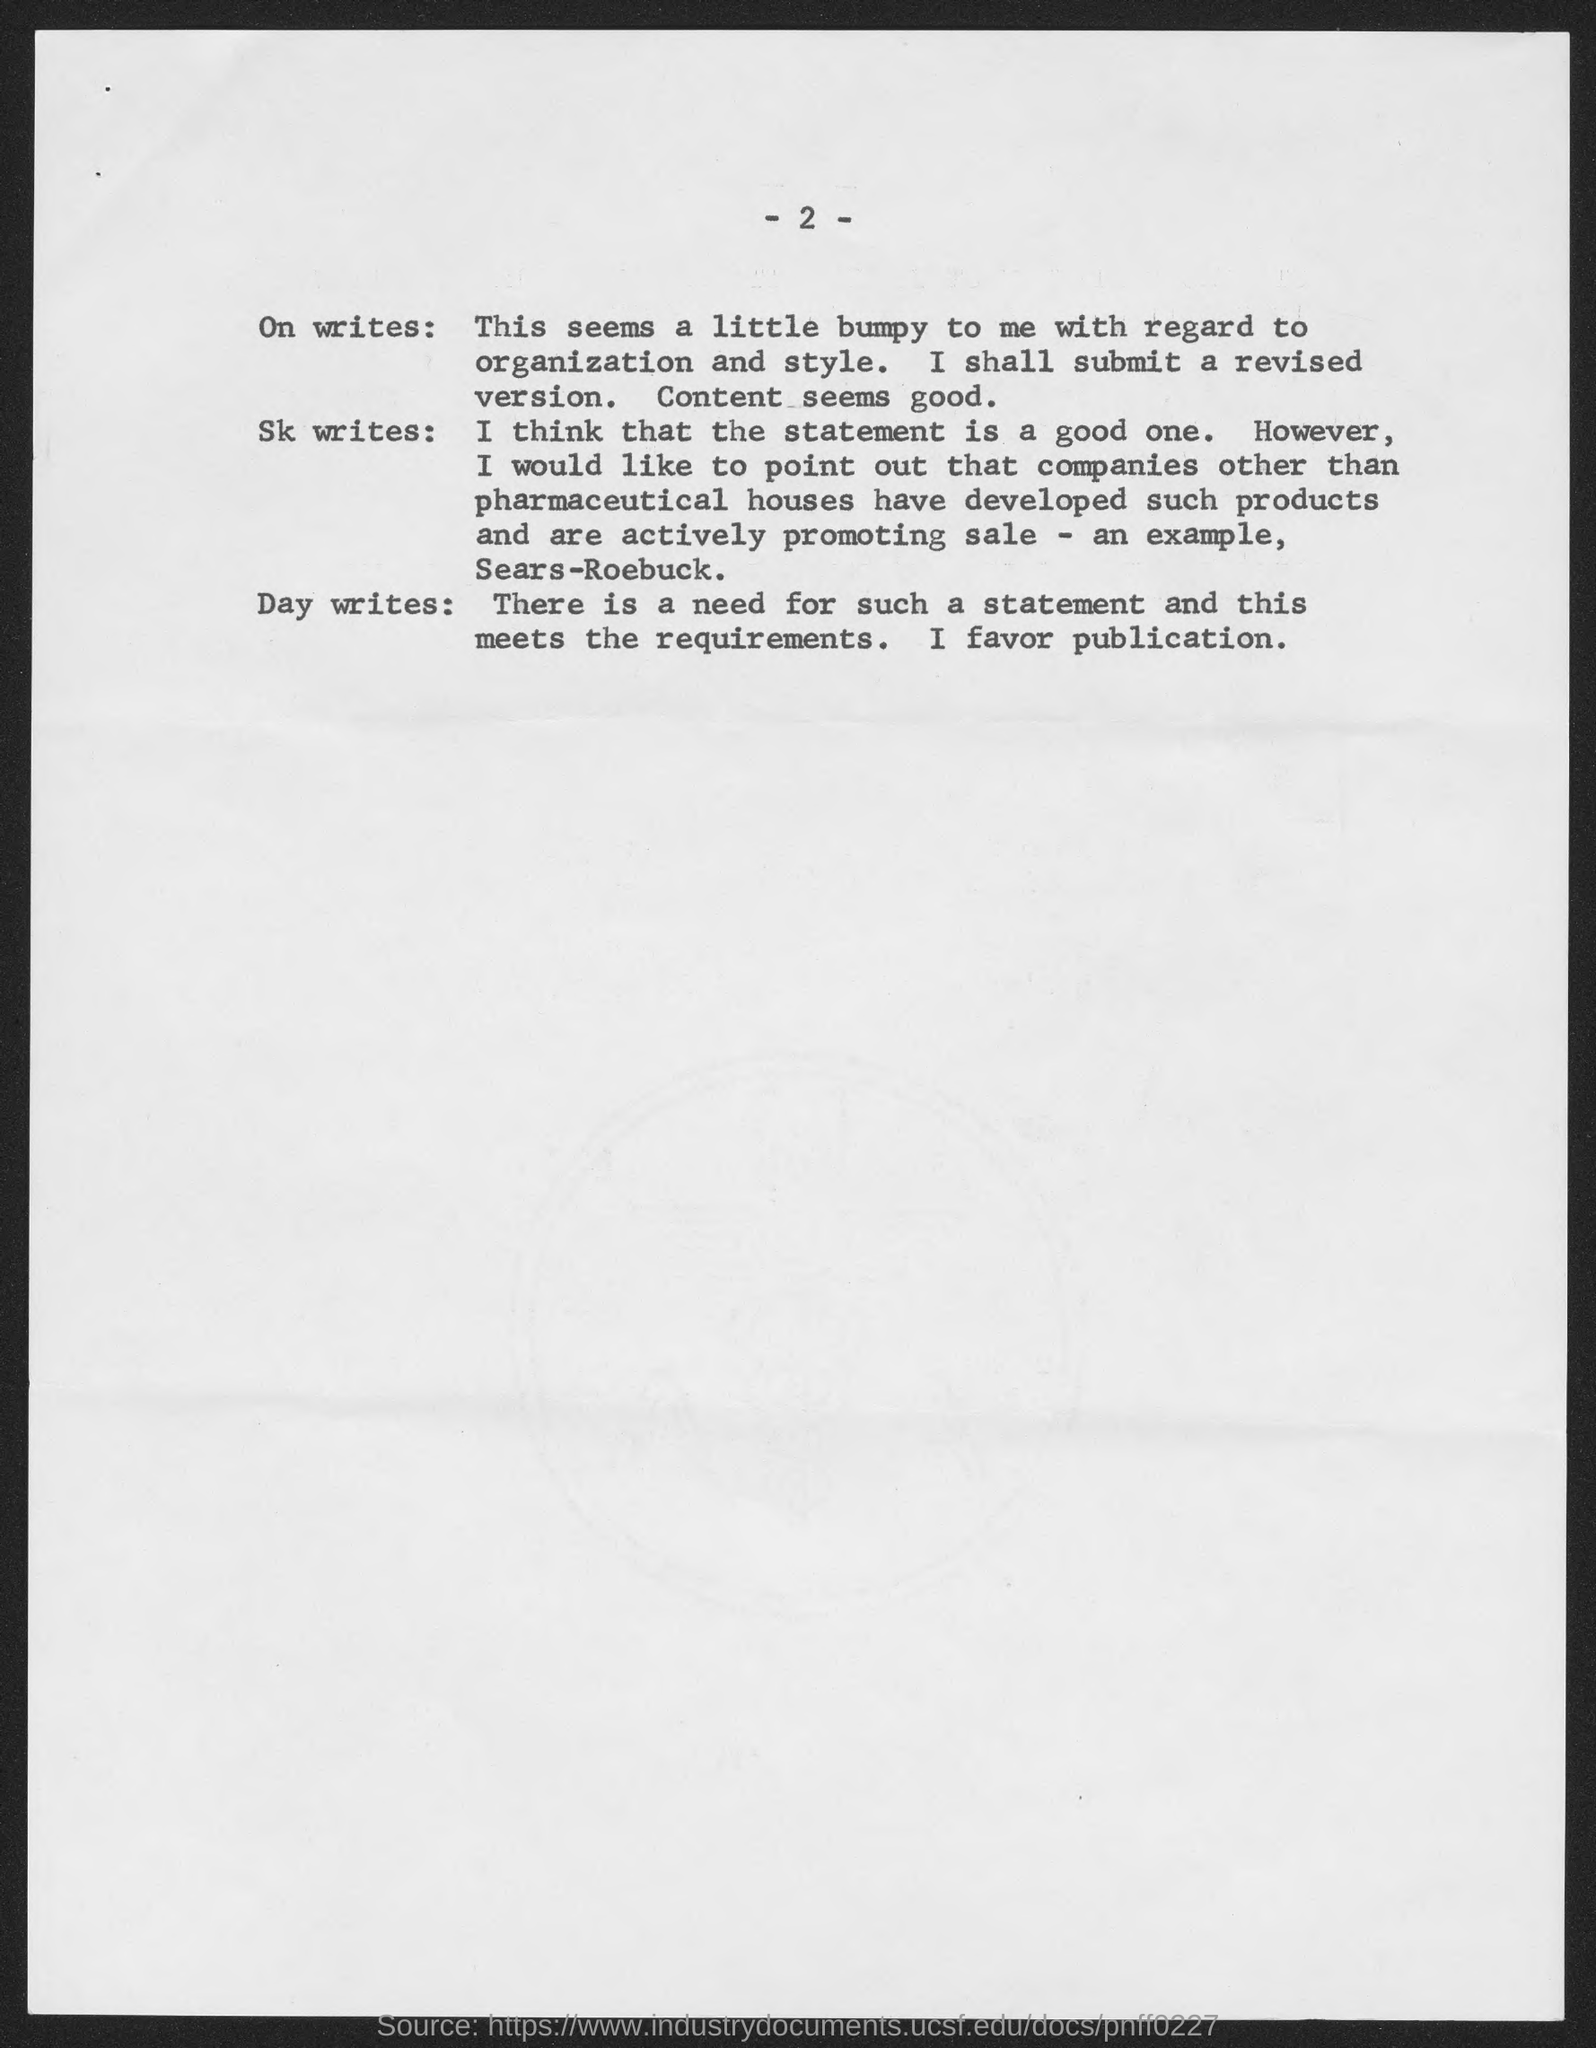Mention a couple of crucial points in this snapshot. The page number mentioned in this document is 2. 